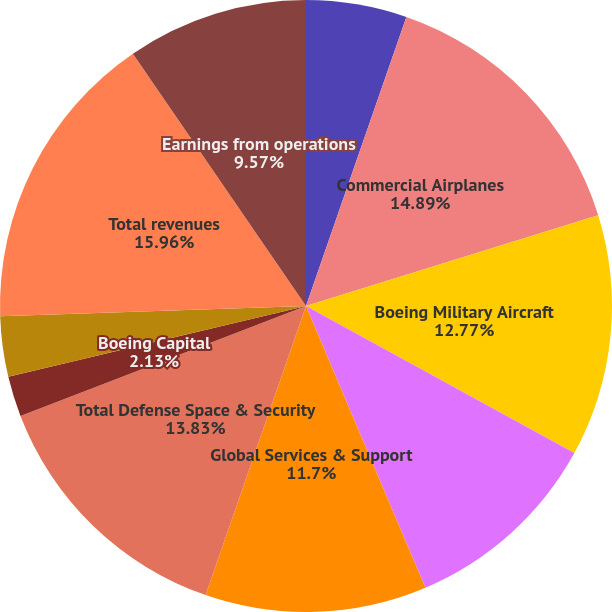Convert chart to OTSL. <chart><loc_0><loc_0><loc_500><loc_500><pie_chart><fcel>Years ended December 31<fcel>Commercial Airplanes<fcel>Boeing Military Aircraft<fcel>Network & Space Systems<fcel>Global Services & Support<fcel>Total Defense Space & Security<fcel>Boeing Capital<fcel>Unallocated items eliminations<fcel>Total revenues<fcel>Earnings from operations<nl><fcel>5.32%<fcel>14.89%<fcel>12.77%<fcel>10.64%<fcel>11.7%<fcel>13.83%<fcel>2.13%<fcel>3.19%<fcel>15.96%<fcel>9.57%<nl></chart> 